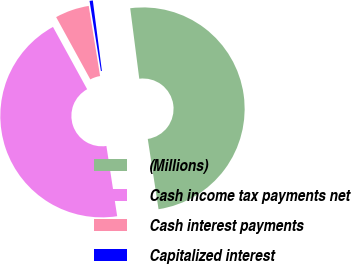Convert chart. <chart><loc_0><loc_0><loc_500><loc_500><pie_chart><fcel>(Millions)<fcel>Cash income tax payments net<fcel>Cash interest payments<fcel>Capitalized interest<nl><fcel>49.62%<fcel>44.44%<fcel>5.43%<fcel>0.52%<nl></chart> 